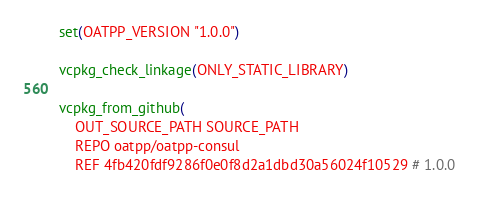Convert code to text. <code><loc_0><loc_0><loc_500><loc_500><_CMake_>set(OATPP_VERSION "1.0.0")

vcpkg_check_linkage(ONLY_STATIC_LIBRARY)

vcpkg_from_github(
    OUT_SOURCE_PATH SOURCE_PATH
    REPO oatpp/oatpp-consul
    REF 4fb420fdf9286f0e0f8d2a1dbd30a56024f10529 # 1.0.0</code> 